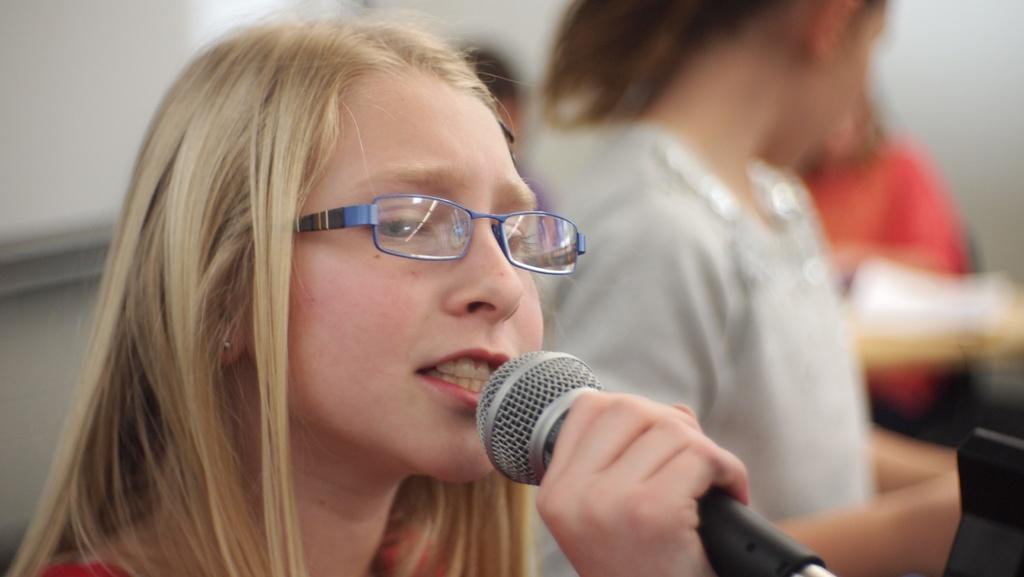Who is the main subject in the image? There is a woman in the image. What is the woman holding in her hand? The woman is holding a microphone in her hand. What is the weather like in the alley where the woman is standing? There is no alley present in the image, and therefore no information about the weather can be provided. 